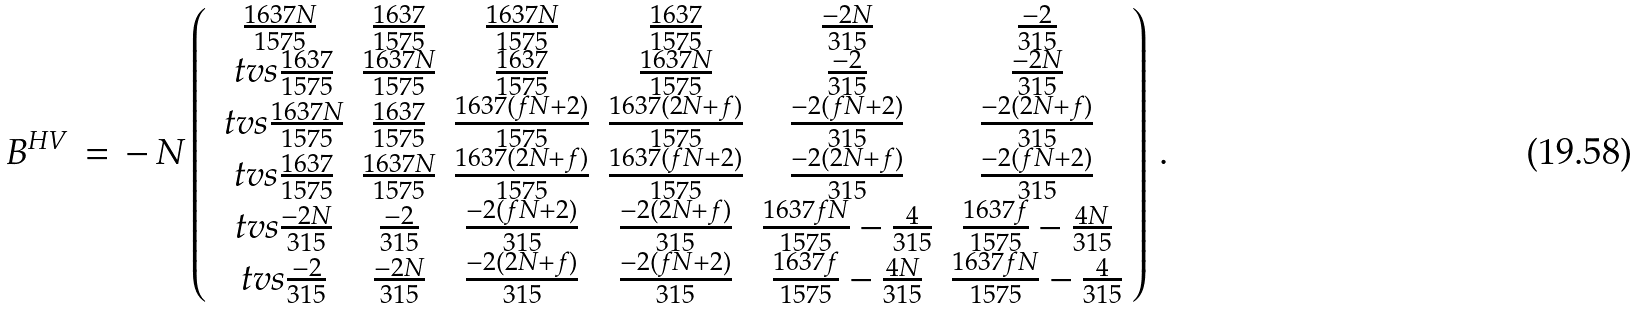<formula> <loc_0><loc_0><loc_500><loc_500>B ^ { H V } \, = \, - \, N \left ( \begin{array} { c c c c c c } \frac { 1 6 3 7 N } { 1 5 7 5 } & \frac { 1 6 3 7 } { 1 5 7 5 } & \frac { 1 6 3 7 N } { 1 5 7 5 } & \frac { 1 6 3 7 } { 1 5 7 5 } & \frac { - 2 N } { 3 1 5 } & \frac { - 2 } { 3 1 5 } \\ \ t v s \frac { 1 6 3 7 } { 1 5 7 5 } & \frac { 1 6 3 7 N } { 1 5 7 5 } & \frac { 1 6 3 7 } { 1 5 7 5 } & \frac { 1 6 3 7 N } { 1 5 7 5 } & \frac { - 2 } { 3 1 5 } & \frac { - 2 N } { 3 1 5 } \\ \ t v s \frac { 1 6 3 7 N } { 1 5 7 5 } & \frac { 1 6 3 7 } { 1 5 7 5 } & \frac { 1 6 3 7 ( f N + 2 ) } { 1 5 7 5 } & \frac { 1 6 3 7 ( 2 N + f ) } { 1 5 7 5 } & \frac { - 2 ( f N + 2 ) } { 3 1 5 } & \frac { - 2 ( 2 N + f ) } { 3 1 5 } \\ \ t v s \frac { 1 6 3 7 } { 1 5 7 5 } & \frac { 1 6 3 7 N } { 1 5 7 5 } & \frac { 1 6 3 7 ( 2 N + f ) } { 1 5 7 5 } & \frac { 1 6 3 7 ( f N + 2 ) } { 1 5 7 5 } & \frac { - 2 ( 2 N + f ) } { 3 1 5 } & \frac { - 2 ( f N + 2 ) } { 3 1 5 } \\ \ t v s \frac { - 2 N } { 3 1 5 } & \frac { - 2 } { 3 1 5 } & \frac { - 2 ( f N + 2 ) } { 3 1 5 } & \frac { - 2 ( 2 N + f ) } { 3 1 5 } & \frac { 1 6 3 7 f N } { 1 5 7 5 } - \frac { 4 } { 3 1 5 } & \frac { 1 6 3 7 f } { 1 5 7 5 } - \frac { 4 N } { 3 1 5 } \\ \ t v s \frac { - 2 } { 3 1 5 } & \frac { - 2 N } { 3 1 5 } & \frac { - 2 ( 2 N + f ) } { 3 1 5 } & \frac { - 2 ( f N + 2 ) } { 3 1 5 } & \frac { 1 6 3 7 f } { 1 5 7 5 } - \frac { 4 N } { 3 1 5 } & \frac { 1 6 3 7 f N } { 1 5 7 5 } - \frac { 4 } { 3 1 5 } \end{array} \right ) \, .</formula> 